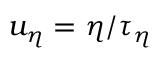<formula> <loc_0><loc_0><loc_500><loc_500>u _ { \eta } = \eta / \tau _ { \eta }</formula> 